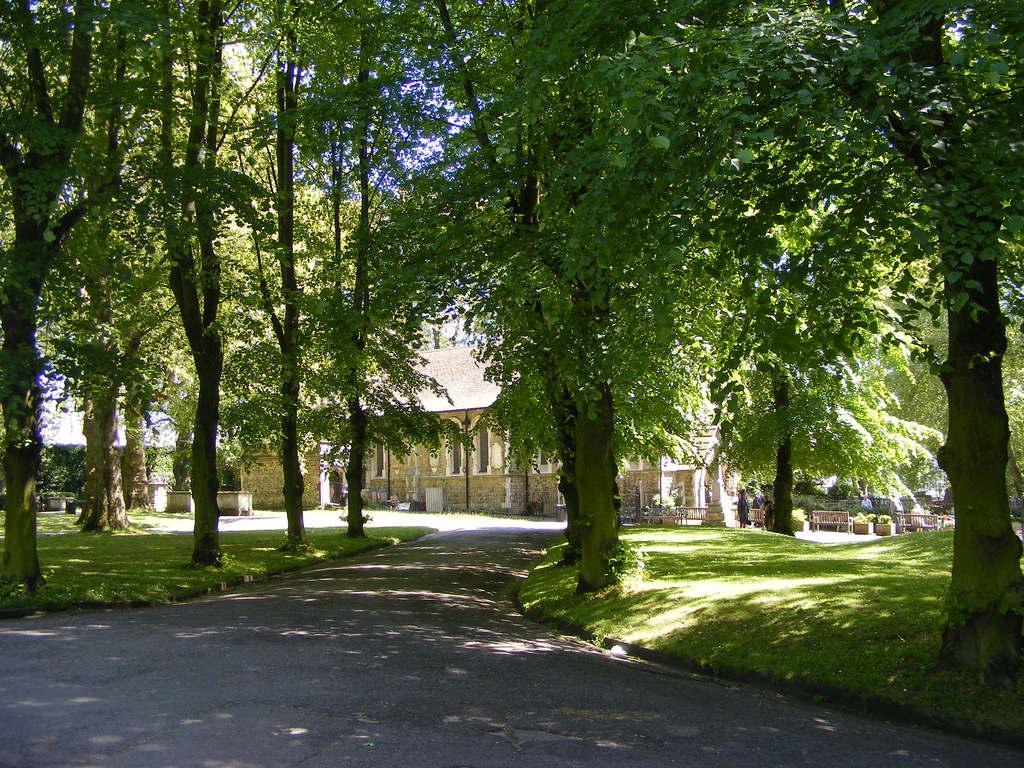In one or two sentences, can you explain what this image depicts? In the background we can see a house, people, benches, plants and few objects. In this picture we can see the trees, green grass and the road. 